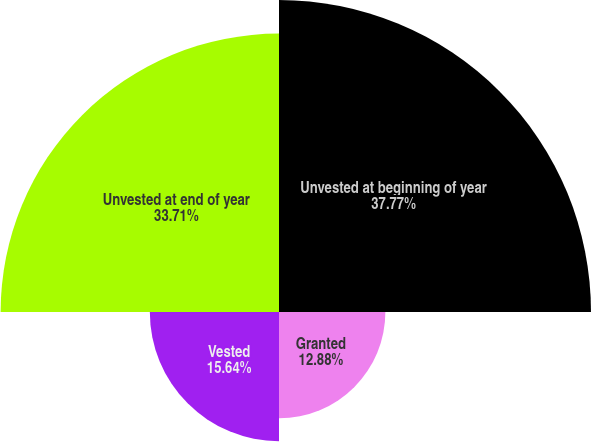Convert chart to OTSL. <chart><loc_0><loc_0><loc_500><loc_500><pie_chart><fcel>Unvested at beginning of year<fcel>Granted<fcel>Vested<fcel>Unvested at end of year<nl><fcel>37.78%<fcel>12.88%<fcel>15.64%<fcel>33.71%<nl></chart> 